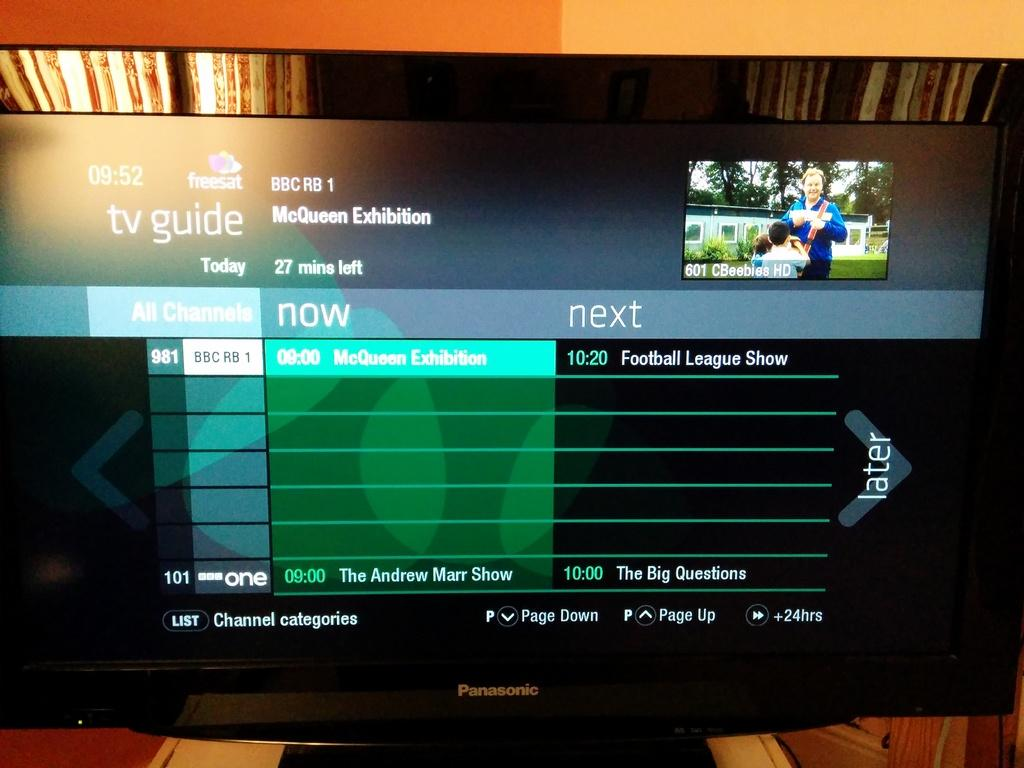Provide a one-sentence caption for the provided image. the tv guide and what is on now and next. 